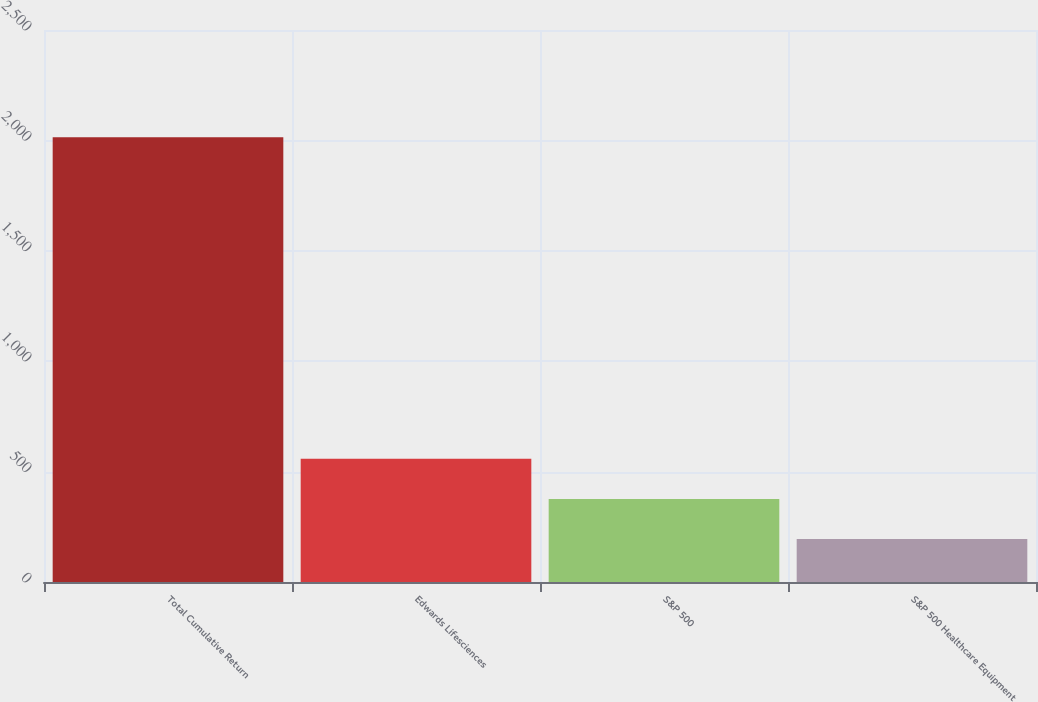<chart> <loc_0><loc_0><loc_500><loc_500><bar_chart><fcel>Total Cumulative Return<fcel>Edwards Lifesciences<fcel>S&P 500<fcel>S&P 500 Healthcare Equipment<nl><fcel>2014<fcel>558.27<fcel>376.3<fcel>194.33<nl></chart> 